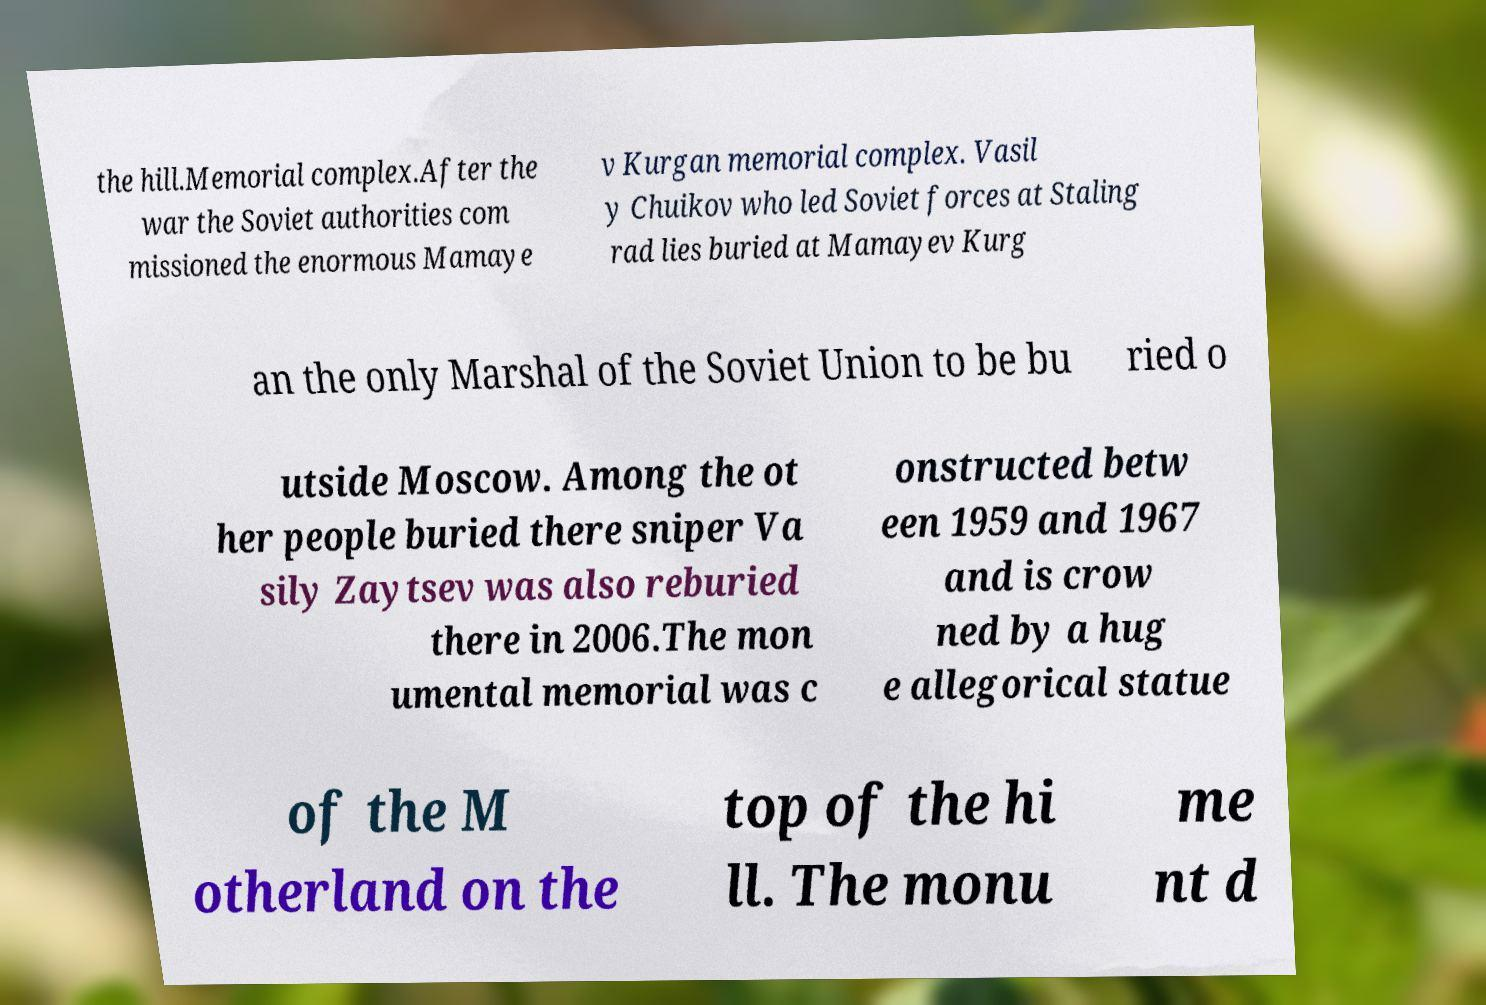There's text embedded in this image that I need extracted. Can you transcribe it verbatim? the hill.Memorial complex.After the war the Soviet authorities com missioned the enormous Mamaye v Kurgan memorial complex. Vasil y Chuikov who led Soviet forces at Staling rad lies buried at Mamayev Kurg an the only Marshal of the Soviet Union to be bu ried o utside Moscow. Among the ot her people buried there sniper Va sily Zaytsev was also reburied there in 2006.The mon umental memorial was c onstructed betw een 1959 and 1967 and is crow ned by a hug e allegorical statue of the M otherland on the top of the hi ll. The monu me nt d 